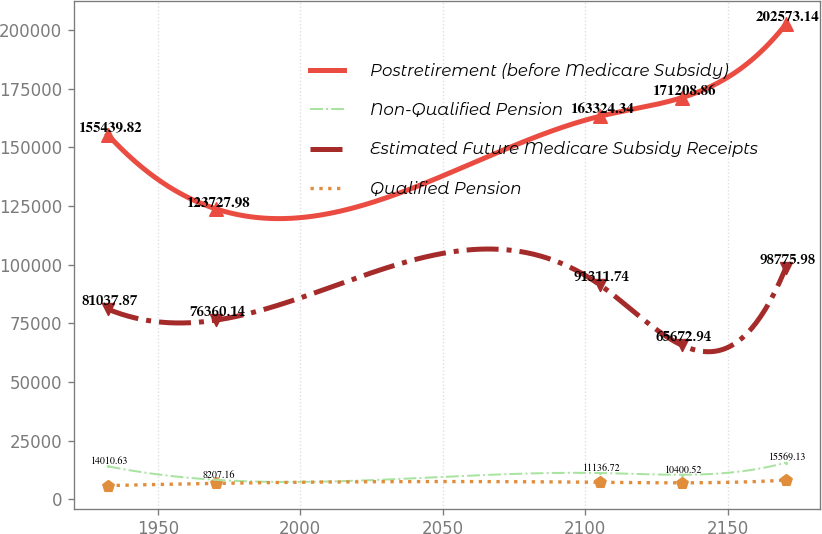Convert chart to OTSL. <chart><loc_0><loc_0><loc_500><loc_500><line_chart><ecel><fcel>Postretirement (before Medicare Subsidy)<fcel>Non-Qualified Pension<fcel>Estimated Future Medicare Subsidy Receipts<fcel>Qualified Pension<nl><fcel>1932.42<fcel>155440<fcel>14010.6<fcel>81037.9<fcel>5765.71<nl><fcel>1970.53<fcel>123728<fcel>8207.16<fcel>76360.1<fcel>6714.4<nl><fcel>2105.26<fcel>163324<fcel>11136.7<fcel>91311.7<fcel>7182.88<nl><fcel>2133.93<fcel>171209<fcel>10400.5<fcel>65672.9<fcel>6948.64<nl><fcel>2170.46<fcel>202573<fcel>15569.1<fcel>98776<fcel>8108.13<nl></chart> 